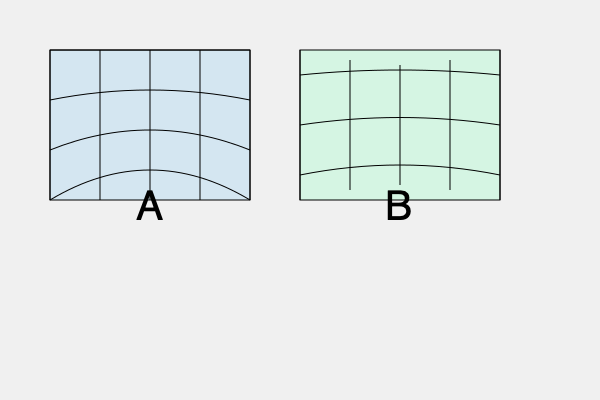As a historian specializing in old maps, you come across two different world map projections labeled A and B. Based on the visual distortions present in each projection, identify which one represents the Mercator projection and which one represents the Robinson projection. To identify the map projections, we need to analyze the distinctive characteristics of each:

1. Projection A:
   - Shows significant vertical stretching towards the poles
   - Parallel lines of latitude are straight and equally spaced
   - Meridians are straight, vertical, and equally spaced
   These characteristics are typical of the Mercator projection, which preserves angles but distorts area, especially near the poles.

2. Projection B:
   - Shows less distortion at the poles compared to A
   - Parallel lines of latitude are curved
   - Meridians are curved, with spacing increasing towards the poles
   These features are consistent with the Robinson projection, which attempts to balance various distortions for a more visually appealing world map.

3. Key differences:
   - Mercator (A) exaggerates polar regions, while Robinson (B) reduces this distortion
   - Mercator has straight parallels and meridians, while Robinson uses curved lines
   - Robinson appears more elliptical overall, compared to Mercator's rectangular shape

4. Historical context:
   - Mercator (1569) was designed for navigation, preserving direction
   - Robinson (1963) was created to present a more visually balanced world map

Therefore, Projection A is the Mercator projection, and Projection B is the Robinson projection.
Answer: A: Mercator, B: Robinson 